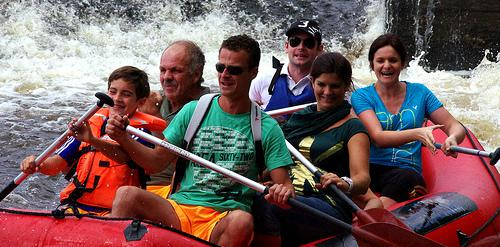Question: where was this picture taken?
Choices:
A. In a house.
B. On a river.
C. Under a bridge.
D. Near a school.
Answer with the letter. Answer: B Question: how many people are wearing life vests?
Choices:
A. One.
B. Two.
C. None.
D. Three.
Answer with the letter. Answer: B Question: how many females are in the raft?
Choices:
A. One.
B. Two.
C. None.
D. Four.
Answer with the letter. Answer: B Question: how many males are in the photograph?
Choices:
A. Three.
B. Four.
C. Five.
D. Six.
Answer with the letter. Answer: B Question: how many children are in the raft?
Choices:
A. One.
B. Zero.
C. Two.
D. Three.
Answer with the letter. Answer: A Question: how many people are the picture?
Choices:
A. Seven.
B. Six.
C. Five.
D. Four.
Answer with the letter. Answer: B 